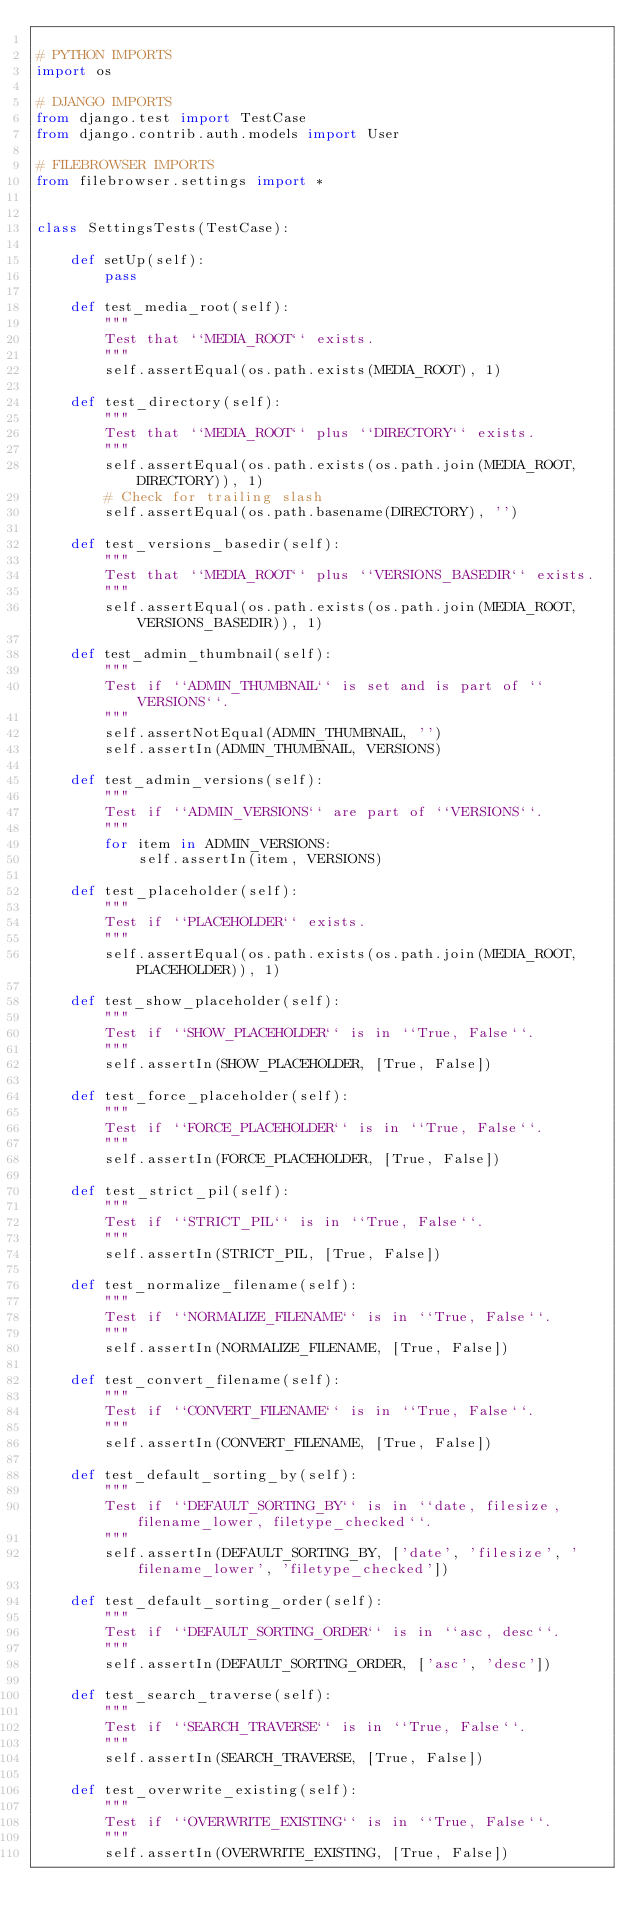<code> <loc_0><loc_0><loc_500><loc_500><_Python_>
# PYTHON IMPORTS
import os

# DJANGO IMPORTS
from django.test import TestCase
from django.contrib.auth.models import User

# FILEBROWSER IMPORTS
from filebrowser.settings import *


class SettingsTests(TestCase):

    def setUp(self):
        pass

    def test_media_root(self):
        """
        Test that ``MEDIA_ROOT`` exists.
        """
        self.assertEqual(os.path.exists(MEDIA_ROOT), 1)

    def test_directory(self):
        """
        Test that ``MEDIA_ROOT`` plus ``DIRECTORY`` exists.
        """
        self.assertEqual(os.path.exists(os.path.join(MEDIA_ROOT, DIRECTORY)), 1)
        # Check for trailing slash
        self.assertEqual(os.path.basename(DIRECTORY), '')

    def test_versions_basedir(self):
        """
        Test that ``MEDIA_ROOT`` plus ``VERSIONS_BASEDIR`` exists.
        """
        self.assertEqual(os.path.exists(os.path.join(MEDIA_ROOT, VERSIONS_BASEDIR)), 1)

    def test_admin_thumbnail(self):
        """
        Test if ``ADMIN_THUMBNAIL`` is set and is part of ``VERSIONS``.
        """
        self.assertNotEqual(ADMIN_THUMBNAIL, '')
        self.assertIn(ADMIN_THUMBNAIL, VERSIONS)

    def test_admin_versions(self):
        """
        Test if ``ADMIN_VERSIONS`` are part of ``VERSIONS``.
        """
        for item in ADMIN_VERSIONS:
            self.assertIn(item, VERSIONS)

    def test_placeholder(self):
        """
        Test if ``PLACEHOLDER`` exists.
        """
        self.assertEqual(os.path.exists(os.path.join(MEDIA_ROOT, PLACEHOLDER)), 1)

    def test_show_placeholder(self):
        """
        Test if ``SHOW_PLACEHOLDER`` is in ``True, False``.
        """
        self.assertIn(SHOW_PLACEHOLDER, [True, False])

    def test_force_placeholder(self):
        """
        Test if ``FORCE_PLACEHOLDER`` is in ``True, False``.
        """
        self.assertIn(FORCE_PLACEHOLDER, [True, False])

    def test_strict_pil(self):
        """
        Test if ``STRICT_PIL`` is in ``True, False``.
        """
        self.assertIn(STRICT_PIL, [True, False])

    def test_normalize_filename(self):
        """
        Test if ``NORMALIZE_FILENAME`` is in ``True, False``.
        """
        self.assertIn(NORMALIZE_FILENAME, [True, False])

    def test_convert_filename(self):
        """
        Test if ``CONVERT_FILENAME`` is in ``True, False``.
        """
        self.assertIn(CONVERT_FILENAME, [True, False])

    def test_default_sorting_by(self):
        """
        Test if ``DEFAULT_SORTING_BY`` is in ``date, filesize, filename_lower, filetype_checked``.
        """
        self.assertIn(DEFAULT_SORTING_BY, ['date', 'filesize', 'filename_lower', 'filetype_checked'])

    def test_default_sorting_order(self):
        """
        Test if ``DEFAULT_SORTING_ORDER`` is in ``asc, desc``.
        """
        self.assertIn(DEFAULT_SORTING_ORDER, ['asc', 'desc'])

    def test_search_traverse(self):
        """
        Test if ``SEARCH_TRAVERSE`` is in ``True, False``.
        """
        self.assertIn(SEARCH_TRAVERSE, [True, False])

    def test_overwrite_existing(self):
        """
        Test if ``OVERWRITE_EXISTING`` is in ``True, False``.
        """
        self.assertIn(OVERWRITE_EXISTING, [True, False])
</code> 